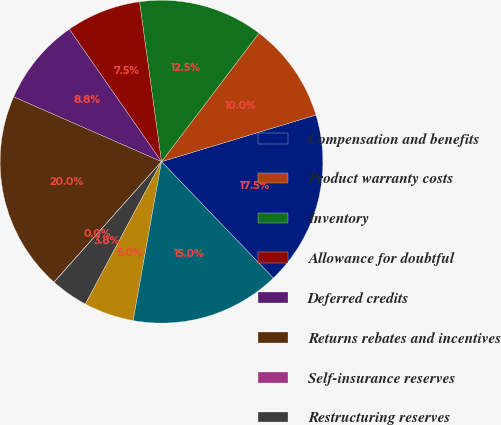Convert chart to OTSL. <chart><loc_0><loc_0><loc_500><loc_500><pie_chart><fcel>Compensation and benefits<fcel>Product warranty costs<fcel>Inventory<fcel>Allowance for doubtful<fcel>Deferred credits<fcel>Returns rebates and incentives<fcel>Self-insurance reserves<fcel>Restructuring reserves<fcel>Net operating loss<fcel>Other - net<nl><fcel>17.49%<fcel>10.0%<fcel>12.5%<fcel>7.5%<fcel>8.75%<fcel>19.98%<fcel>0.02%<fcel>3.76%<fcel>5.01%<fcel>14.99%<nl></chart> 